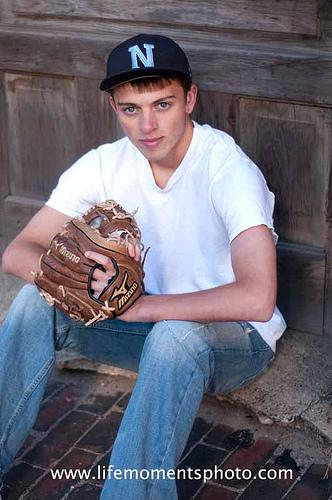Use a brief description focusing primarily on the boy's appearance. Young man with blue eyes, brown hair and a white shirt is wearing blue jeans, a black hat with a light blue logo, and a brown leather glove. Create a concise description of the scene shown in the image, focusing on the subject and their accessories. A blue-eyed boy in a white shirt, black hat with a blue emblem, and blue jeans holds a brown baseball glove while seated on a brick floor. Portray the image in a comprehensive sentence, highlighting the most important aspects. A young man with brown hair, wearing a white shirt, blue jeans, black hat with blue 'n', and brown glove, sits on a red brick pathway. What are the most prominent objects and elements in the image? A boy wearing a white shirt, blue jeans, and black cap with blue 'n' on sits on a red brick walkway holding a brown leather baseball glove. Mention the key objects and colors present in the image. A young man wearing a white shirt, blue jeans, and a black baseball cap with a blue 'n' on it holds a brown leather baseball glove while sitting on red brick ground. Describe the main subject, including their attire and specific features, in a concise manner. A blue-eyed young man in a white shirt, blue pants, and black hat with blue logo sits on a brick surface, holding a brown baseball glove. Summarize the scene depicted in the image using short, to-the-point sentences. Boy in a white shirt and blue jeans sits on bricks. Wears black hat with a blue 'n' and brown leather glove. Describe the boy and his attire in the image. The boy has brown hair, blue eyes, and a short haircut, wearing a white shirt, blue jeans, a black and white baseball cap with a blue logo, and a brown leather baseball glove. Explain what activity the boy in the image is engaging in. The boy in the image is sitting down on a brick walkway and holding a brown leather baseball glove, possibly preparing to play catch or practice. Describe the boy's appearance and what he's holding in the image. A boy with short brown hair, blue eyes, and a black cap is wearing a white shirt and blue jeans while holding a brown leather baseball glove. 